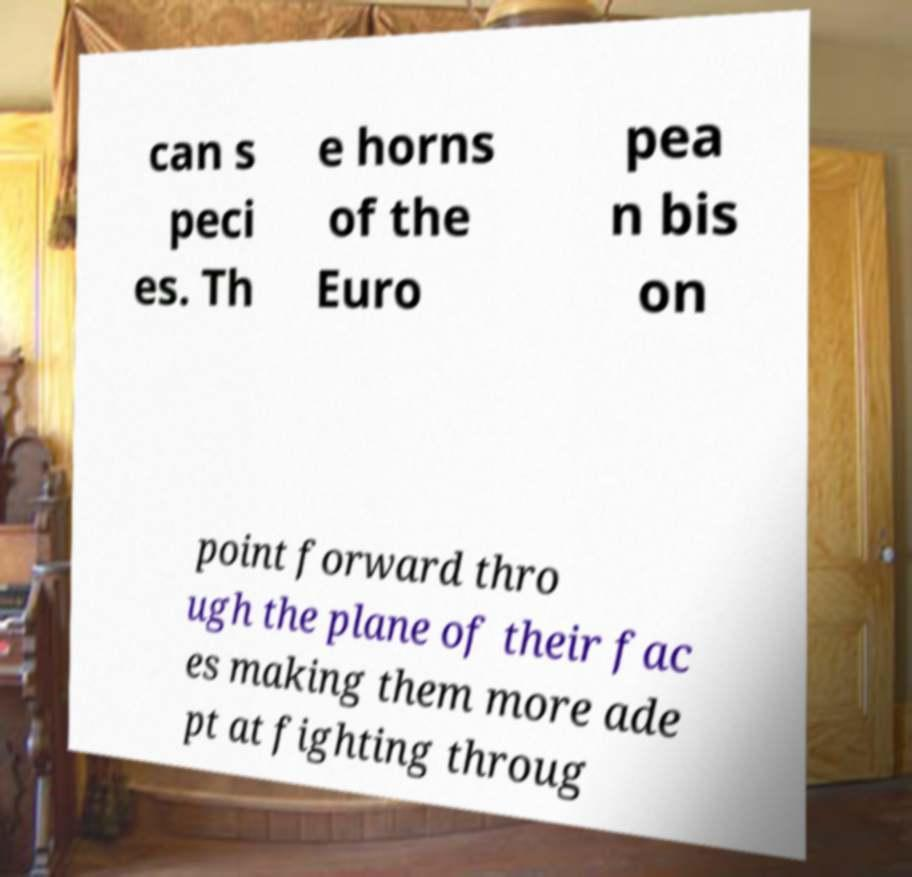I need the written content from this picture converted into text. Can you do that? can s peci es. Th e horns of the Euro pea n bis on point forward thro ugh the plane of their fac es making them more ade pt at fighting throug 